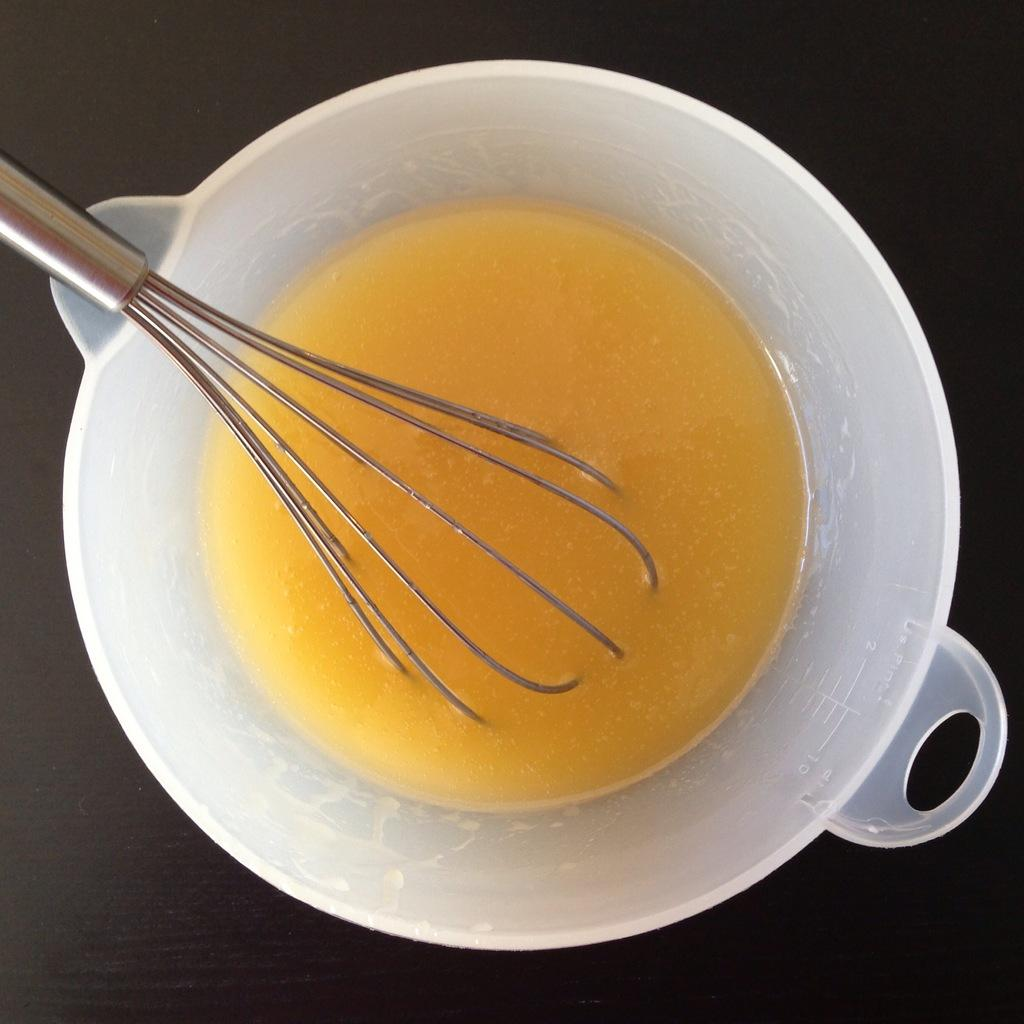What is in the bowl that is visible in the image? The bowl contains a whisked egg. What tool is used to whisk the egg in the image? There is a whisker in the bowl. Where was the image taken? The image is taken in a room. What is the profit made from the whisked egg in the image? There is no mention of profit or any financial aspect related to the whisked egg in the image. 